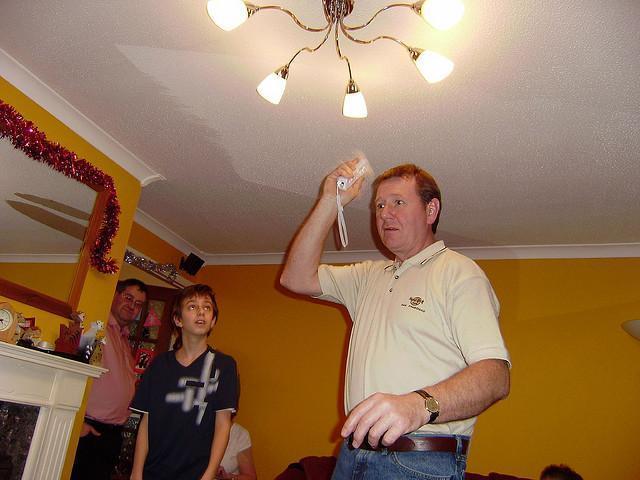How many people are in the photo?
Give a very brief answer. 3. 